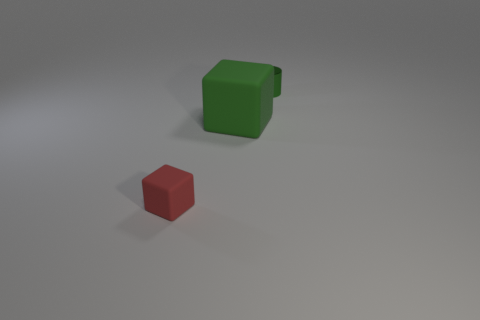Add 2 green matte cubes. How many objects exist? 5 Subtract all blocks. How many objects are left? 1 Add 1 rubber blocks. How many rubber blocks exist? 3 Subtract 0 yellow spheres. How many objects are left? 3 Subtract all green objects. Subtract all big green shiny things. How many objects are left? 1 Add 3 cylinders. How many cylinders are left? 4 